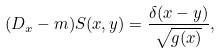<formula> <loc_0><loc_0><loc_500><loc_500>( \sl D _ { x } - m ) S ( x , y ) = \frac { \delta ( x - y ) } { \sqrt { g ( x ) } } ,</formula> 